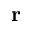Convert formula to latex. <formula><loc_0><loc_0><loc_500><loc_500>r</formula> 